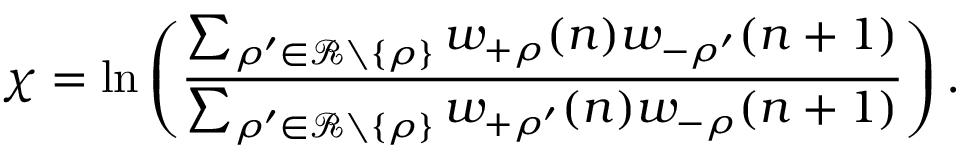<formula> <loc_0><loc_0><loc_500><loc_500>\chi = \ln \left ( \frac { \sum _ { \rho ^ { \prime } \in \mathcal { R } \ \{ \rho \} } w _ { + \rho } ( n ) w _ { - \rho ^ { \prime } } ( n + 1 ) } { \sum _ { \rho ^ { \prime } \in \mathcal { R } \ \{ \rho \} } w _ { + \rho ^ { \prime } } ( n ) w _ { - \rho } ( n + 1 ) } \right ) .</formula> 